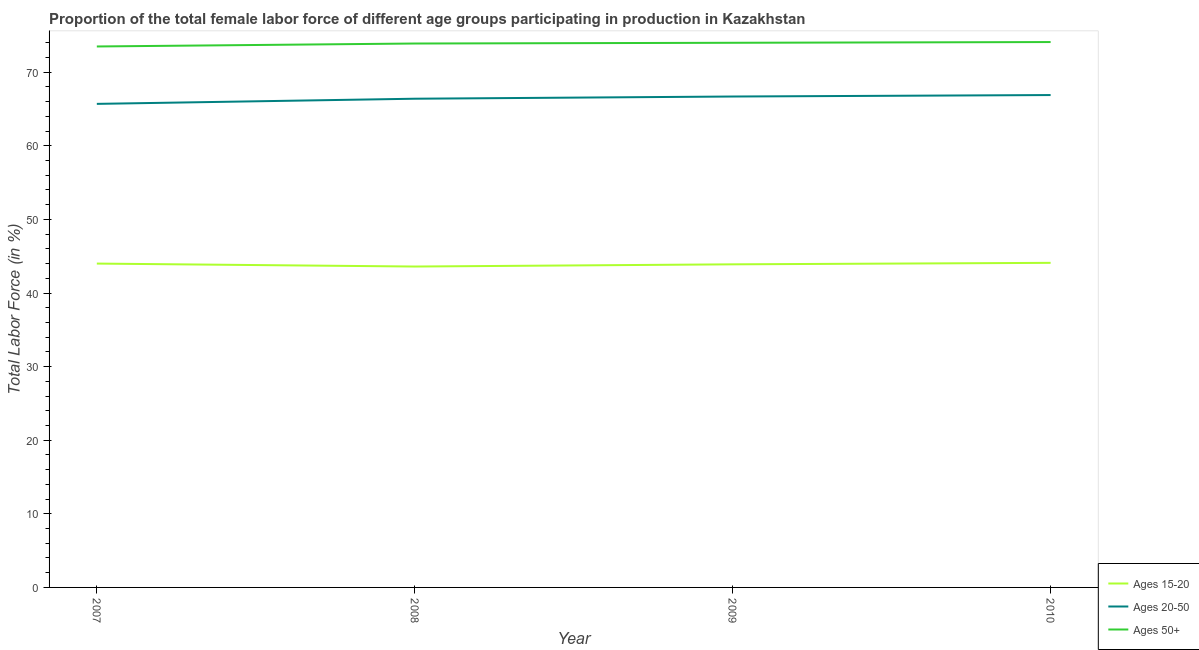How many different coloured lines are there?
Offer a terse response. 3. Is the number of lines equal to the number of legend labels?
Ensure brevity in your answer.  Yes. What is the percentage of female labor force within the age group 15-20 in 2008?
Offer a very short reply. 43.6. Across all years, what is the maximum percentage of female labor force within the age group 15-20?
Offer a terse response. 44.1. Across all years, what is the minimum percentage of female labor force within the age group 15-20?
Your answer should be very brief. 43.6. What is the total percentage of female labor force within the age group 20-50 in the graph?
Keep it short and to the point. 265.7. What is the difference between the percentage of female labor force within the age group 15-20 in 2007 and that in 2009?
Make the answer very short. 0.1. What is the difference between the percentage of female labor force within the age group 20-50 in 2008 and the percentage of female labor force above age 50 in 2010?
Make the answer very short. -7.7. What is the average percentage of female labor force within the age group 20-50 per year?
Offer a terse response. 66.42. In the year 2010, what is the difference between the percentage of female labor force within the age group 20-50 and percentage of female labor force within the age group 15-20?
Offer a very short reply. 22.8. In how many years, is the percentage of female labor force within the age group 20-50 greater than 14 %?
Make the answer very short. 4. What is the ratio of the percentage of female labor force above age 50 in 2007 to that in 2009?
Offer a terse response. 0.99. Is the difference between the percentage of female labor force above age 50 in 2008 and 2010 greater than the difference between the percentage of female labor force within the age group 20-50 in 2008 and 2010?
Offer a very short reply. Yes. What is the difference between the highest and the second highest percentage of female labor force within the age group 15-20?
Your response must be concise. 0.1. What is the difference between the highest and the lowest percentage of female labor force within the age group 15-20?
Offer a terse response. 0.5. Is the sum of the percentage of female labor force within the age group 15-20 in 2008 and 2010 greater than the maximum percentage of female labor force above age 50 across all years?
Your response must be concise. Yes. Is it the case that in every year, the sum of the percentage of female labor force within the age group 15-20 and percentage of female labor force within the age group 20-50 is greater than the percentage of female labor force above age 50?
Provide a short and direct response. Yes. Is the percentage of female labor force above age 50 strictly greater than the percentage of female labor force within the age group 15-20 over the years?
Give a very brief answer. Yes. How many lines are there?
Your answer should be compact. 3. What is the difference between two consecutive major ticks on the Y-axis?
Ensure brevity in your answer.  10. Are the values on the major ticks of Y-axis written in scientific E-notation?
Make the answer very short. No. Does the graph contain any zero values?
Offer a very short reply. No. Where does the legend appear in the graph?
Your response must be concise. Bottom right. How are the legend labels stacked?
Provide a succinct answer. Vertical. What is the title of the graph?
Give a very brief answer. Proportion of the total female labor force of different age groups participating in production in Kazakhstan. Does "Secondary" appear as one of the legend labels in the graph?
Your answer should be compact. No. What is the label or title of the Y-axis?
Keep it short and to the point. Total Labor Force (in %). What is the Total Labor Force (in %) in Ages 15-20 in 2007?
Provide a succinct answer. 44. What is the Total Labor Force (in %) in Ages 20-50 in 2007?
Give a very brief answer. 65.7. What is the Total Labor Force (in %) of Ages 50+ in 2007?
Make the answer very short. 73.5. What is the Total Labor Force (in %) in Ages 15-20 in 2008?
Give a very brief answer. 43.6. What is the Total Labor Force (in %) of Ages 20-50 in 2008?
Offer a terse response. 66.4. What is the Total Labor Force (in %) of Ages 50+ in 2008?
Offer a very short reply. 73.9. What is the Total Labor Force (in %) in Ages 15-20 in 2009?
Keep it short and to the point. 43.9. What is the Total Labor Force (in %) of Ages 20-50 in 2009?
Ensure brevity in your answer.  66.7. What is the Total Labor Force (in %) of Ages 50+ in 2009?
Your response must be concise. 74. What is the Total Labor Force (in %) of Ages 15-20 in 2010?
Offer a terse response. 44.1. What is the Total Labor Force (in %) of Ages 20-50 in 2010?
Your answer should be compact. 66.9. What is the Total Labor Force (in %) in Ages 50+ in 2010?
Provide a short and direct response. 74.1. Across all years, what is the maximum Total Labor Force (in %) of Ages 15-20?
Ensure brevity in your answer.  44.1. Across all years, what is the maximum Total Labor Force (in %) of Ages 20-50?
Provide a succinct answer. 66.9. Across all years, what is the maximum Total Labor Force (in %) in Ages 50+?
Your response must be concise. 74.1. Across all years, what is the minimum Total Labor Force (in %) of Ages 15-20?
Make the answer very short. 43.6. Across all years, what is the minimum Total Labor Force (in %) in Ages 20-50?
Offer a terse response. 65.7. Across all years, what is the minimum Total Labor Force (in %) in Ages 50+?
Your answer should be compact. 73.5. What is the total Total Labor Force (in %) of Ages 15-20 in the graph?
Offer a very short reply. 175.6. What is the total Total Labor Force (in %) in Ages 20-50 in the graph?
Offer a terse response. 265.7. What is the total Total Labor Force (in %) in Ages 50+ in the graph?
Provide a succinct answer. 295.5. What is the difference between the Total Labor Force (in %) in Ages 50+ in 2007 and that in 2009?
Offer a terse response. -0.5. What is the difference between the Total Labor Force (in %) of Ages 20-50 in 2007 and that in 2010?
Give a very brief answer. -1.2. What is the difference between the Total Labor Force (in %) of Ages 15-20 in 2008 and that in 2009?
Keep it short and to the point. -0.3. What is the difference between the Total Labor Force (in %) of Ages 50+ in 2008 and that in 2009?
Keep it short and to the point. -0.1. What is the difference between the Total Labor Force (in %) of Ages 20-50 in 2008 and that in 2010?
Offer a very short reply. -0.5. What is the difference between the Total Labor Force (in %) in Ages 50+ in 2008 and that in 2010?
Offer a terse response. -0.2. What is the difference between the Total Labor Force (in %) in Ages 20-50 in 2009 and that in 2010?
Keep it short and to the point. -0.2. What is the difference between the Total Labor Force (in %) in Ages 50+ in 2009 and that in 2010?
Give a very brief answer. -0.1. What is the difference between the Total Labor Force (in %) in Ages 15-20 in 2007 and the Total Labor Force (in %) in Ages 20-50 in 2008?
Ensure brevity in your answer.  -22.4. What is the difference between the Total Labor Force (in %) of Ages 15-20 in 2007 and the Total Labor Force (in %) of Ages 50+ in 2008?
Your response must be concise. -29.9. What is the difference between the Total Labor Force (in %) in Ages 20-50 in 2007 and the Total Labor Force (in %) in Ages 50+ in 2008?
Ensure brevity in your answer.  -8.2. What is the difference between the Total Labor Force (in %) in Ages 15-20 in 2007 and the Total Labor Force (in %) in Ages 20-50 in 2009?
Your answer should be very brief. -22.7. What is the difference between the Total Labor Force (in %) in Ages 15-20 in 2007 and the Total Labor Force (in %) in Ages 50+ in 2009?
Make the answer very short. -30. What is the difference between the Total Labor Force (in %) of Ages 15-20 in 2007 and the Total Labor Force (in %) of Ages 20-50 in 2010?
Offer a terse response. -22.9. What is the difference between the Total Labor Force (in %) in Ages 15-20 in 2007 and the Total Labor Force (in %) in Ages 50+ in 2010?
Your response must be concise. -30.1. What is the difference between the Total Labor Force (in %) in Ages 20-50 in 2007 and the Total Labor Force (in %) in Ages 50+ in 2010?
Offer a very short reply. -8.4. What is the difference between the Total Labor Force (in %) of Ages 15-20 in 2008 and the Total Labor Force (in %) of Ages 20-50 in 2009?
Your response must be concise. -23.1. What is the difference between the Total Labor Force (in %) in Ages 15-20 in 2008 and the Total Labor Force (in %) in Ages 50+ in 2009?
Provide a succinct answer. -30.4. What is the difference between the Total Labor Force (in %) of Ages 20-50 in 2008 and the Total Labor Force (in %) of Ages 50+ in 2009?
Provide a short and direct response. -7.6. What is the difference between the Total Labor Force (in %) in Ages 15-20 in 2008 and the Total Labor Force (in %) in Ages 20-50 in 2010?
Give a very brief answer. -23.3. What is the difference between the Total Labor Force (in %) in Ages 15-20 in 2008 and the Total Labor Force (in %) in Ages 50+ in 2010?
Your response must be concise. -30.5. What is the difference between the Total Labor Force (in %) of Ages 15-20 in 2009 and the Total Labor Force (in %) of Ages 50+ in 2010?
Keep it short and to the point. -30.2. What is the difference between the Total Labor Force (in %) of Ages 20-50 in 2009 and the Total Labor Force (in %) of Ages 50+ in 2010?
Offer a very short reply. -7.4. What is the average Total Labor Force (in %) in Ages 15-20 per year?
Your response must be concise. 43.9. What is the average Total Labor Force (in %) of Ages 20-50 per year?
Keep it short and to the point. 66.42. What is the average Total Labor Force (in %) in Ages 50+ per year?
Keep it short and to the point. 73.88. In the year 2007, what is the difference between the Total Labor Force (in %) of Ages 15-20 and Total Labor Force (in %) of Ages 20-50?
Provide a short and direct response. -21.7. In the year 2007, what is the difference between the Total Labor Force (in %) in Ages 15-20 and Total Labor Force (in %) in Ages 50+?
Ensure brevity in your answer.  -29.5. In the year 2007, what is the difference between the Total Labor Force (in %) in Ages 20-50 and Total Labor Force (in %) in Ages 50+?
Ensure brevity in your answer.  -7.8. In the year 2008, what is the difference between the Total Labor Force (in %) of Ages 15-20 and Total Labor Force (in %) of Ages 20-50?
Ensure brevity in your answer.  -22.8. In the year 2008, what is the difference between the Total Labor Force (in %) of Ages 15-20 and Total Labor Force (in %) of Ages 50+?
Offer a very short reply. -30.3. In the year 2009, what is the difference between the Total Labor Force (in %) in Ages 15-20 and Total Labor Force (in %) in Ages 20-50?
Ensure brevity in your answer.  -22.8. In the year 2009, what is the difference between the Total Labor Force (in %) of Ages 15-20 and Total Labor Force (in %) of Ages 50+?
Your answer should be very brief. -30.1. In the year 2010, what is the difference between the Total Labor Force (in %) of Ages 15-20 and Total Labor Force (in %) of Ages 20-50?
Your response must be concise. -22.8. In the year 2010, what is the difference between the Total Labor Force (in %) in Ages 15-20 and Total Labor Force (in %) in Ages 50+?
Your response must be concise. -30. In the year 2010, what is the difference between the Total Labor Force (in %) in Ages 20-50 and Total Labor Force (in %) in Ages 50+?
Provide a short and direct response. -7.2. What is the ratio of the Total Labor Force (in %) in Ages 15-20 in 2007 to that in 2008?
Ensure brevity in your answer.  1.01. What is the ratio of the Total Labor Force (in %) in Ages 20-50 in 2007 to that in 2010?
Your response must be concise. 0.98. What is the ratio of the Total Labor Force (in %) of Ages 20-50 in 2008 to that in 2009?
Keep it short and to the point. 1. What is the ratio of the Total Labor Force (in %) in Ages 15-20 in 2008 to that in 2010?
Offer a very short reply. 0.99. What is the ratio of the Total Labor Force (in %) in Ages 20-50 in 2008 to that in 2010?
Provide a succinct answer. 0.99. What is the ratio of the Total Labor Force (in %) in Ages 20-50 in 2009 to that in 2010?
Provide a succinct answer. 1. What is the ratio of the Total Labor Force (in %) of Ages 50+ in 2009 to that in 2010?
Your response must be concise. 1. What is the difference between the highest and the second highest Total Labor Force (in %) in Ages 15-20?
Offer a very short reply. 0.1. What is the difference between the highest and the second highest Total Labor Force (in %) of Ages 20-50?
Provide a short and direct response. 0.2. What is the difference between the highest and the lowest Total Labor Force (in %) of Ages 15-20?
Your response must be concise. 0.5. What is the difference between the highest and the lowest Total Labor Force (in %) of Ages 50+?
Offer a very short reply. 0.6. 